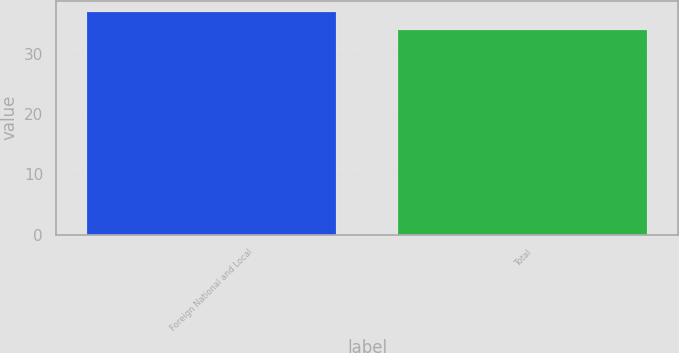Convert chart to OTSL. <chart><loc_0><loc_0><loc_500><loc_500><bar_chart><fcel>Foreign National and Local<fcel>Total<nl><fcel>37<fcel>34<nl></chart> 